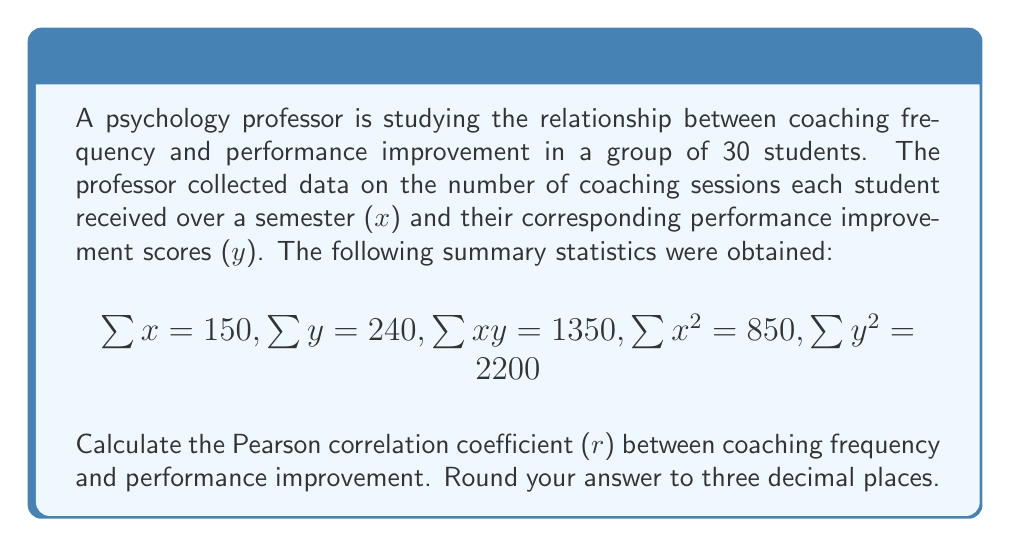Can you solve this math problem? To calculate the Pearson correlation coefficient (r), we'll use the formula:

$$r = \frac{n\sum xy - \sum x \sum y}{\sqrt{[n\sum x^2 - (\sum x)^2][n\sum y^2 - (\sum y)^2]}}$$

Where n is the number of data points (30 in this case).

Step 1: Calculate $n\sum xy$
$n\sum xy = 30 \times 1350 = 40500$

Step 2: Calculate $\sum x \sum y$
$\sum x \sum y = 150 \times 240 = 36000$

Step 3: Calculate the numerator
$n\sum xy - \sum x \sum y = 40500 - 36000 = 4500$

Step 4: Calculate $n\sum x^2$
$n\sum x^2 = 30 \times 850 = 25500$

Step 5: Calculate $(\sum x)^2$
$(\sum x)^2 = 150^2 = 22500$

Step 6: Calculate $n\sum y^2$
$n\sum y^2 = 30 \times 2200 = 66000$

Step 7: Calculate $(\sum y)^2$
$(\sum y)^2 = 240^2 = 57600$

Step 8: Calculate the denominator
$\sqrt{[n\sum x^2 - (\sum x)^2][n\sum y^2 - (\sum y)^2]}$
$= \sqrt{(25500 - 22500)(66000 - 57600)}$
$= \sqrt{3000 \times 8400}$
$= \sqrt{25200000}$
$= 5020$

Step 9: Calculate r
$r = \frac{4500}{5020} = 0.896$

Step 10: Round to three decimal places
$r = 0.896$
Answer: 0.896 